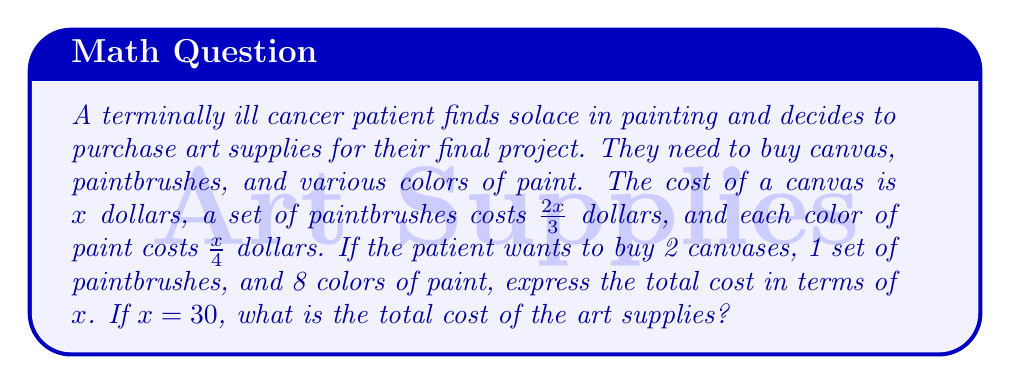Teach me how to tackle this problem. Let's break down the problem step by step:

1. Express the cost of each item in terms of $x$:
   - Canvas: $x$ dollars
   - Set of paintbrushes: $\frac{2x}{3}$ dollars
   - Each color of paint: $\frac{x}{4}$ dollars

2. Calculate the cost for each type of item:
   - 2 canvases: $2x$
   - 1 set of paintbrushes: $\frac{2x}{3}$
   - 8 colors of paint: $8 \cdot \frac{x}{4} = 2x$

3. Sum up the total cost in terms of $x$:
   $$ \text{Total cost} = 2x + \frac{2x}{3} + 2x $$

4. Simplify the expression:
   $$ \text{Total cost} = 4x + \frac{2x}{3} = \frac{12x}{3} + \frac{2x}{3} = \frac{14x}{3} $$

5. If $x = 30$, substitute this value into the expression:
   $$ \text{Total cost} = \frac{14 \cdot 30}{3} = \frac{420}{3} = 140 $$

Therefore, the total cost of the art supplies when $x = 30$ is $140 dollars.
Answer: The total cost in terms of $x$ is $\frac{14x}{3}$ dollars. When $x = 30$, the total cost is $140 dollars. 